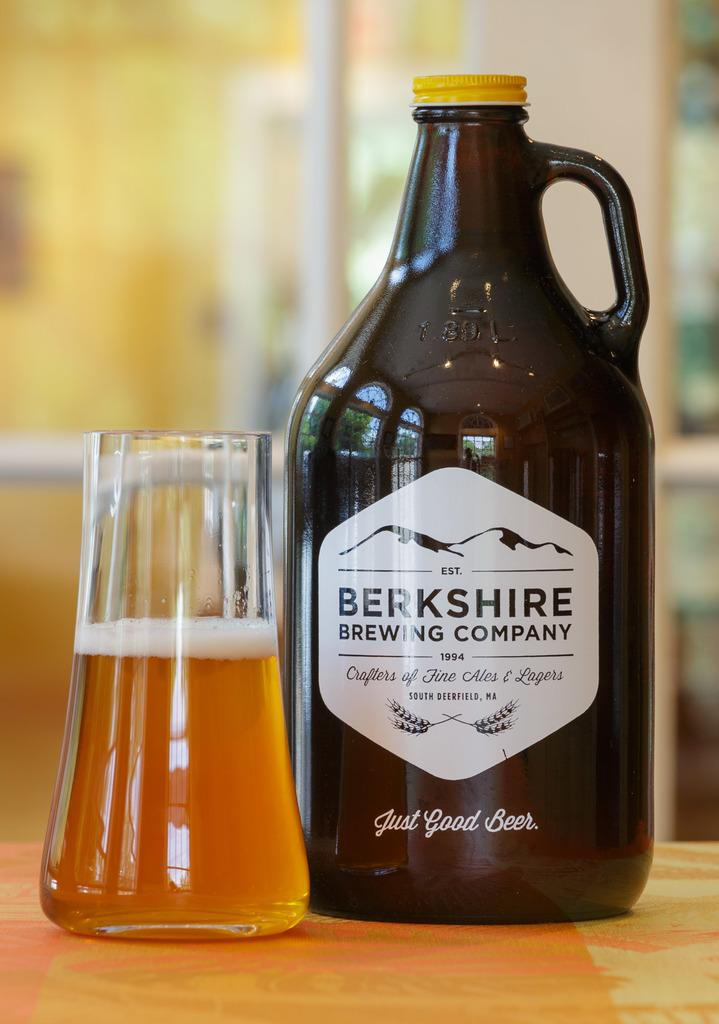Provide a one-sentence caption for the provided image. a jug and glass of Berkshire Brewing Company beer. 